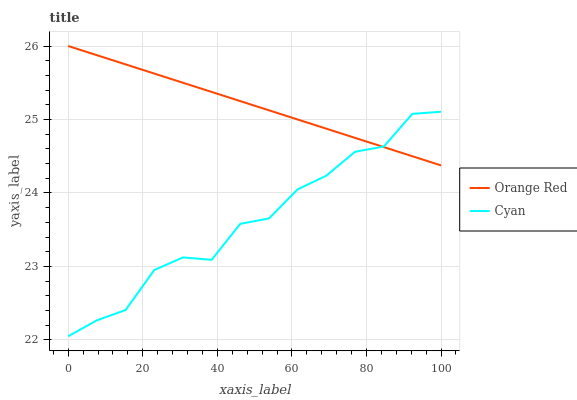Does Cyan have the minimum area under the curve?
Answer yes or no. Yes. Does Orange Red have the maximum area under the curve?
Answer yes or no. Yes. Does Orange Red have the minimum area under the curve?
Answer yes or no. No. Is Orange Red the smoothest?
Answer yes or no. Yes. Is Cyan the roughest?
Answer yes or no. Yes. Is Orange Red the roughest?
Answer yes or no. No. Does Cyan have the lowest value?
Answer yes or no. Yes. Does Orange Red have the lowest value?
Answer yes or no. No. Does Orange Red have the highest value?
Answer yes or no. Yes. Does Cyan intersect Orange Red?
Answer yes or no. Yes. Is Cyan less than Orange Red?
Answer yes or no. No. Is Cyan greater than Orange Red?
Answer yes or no. No. 